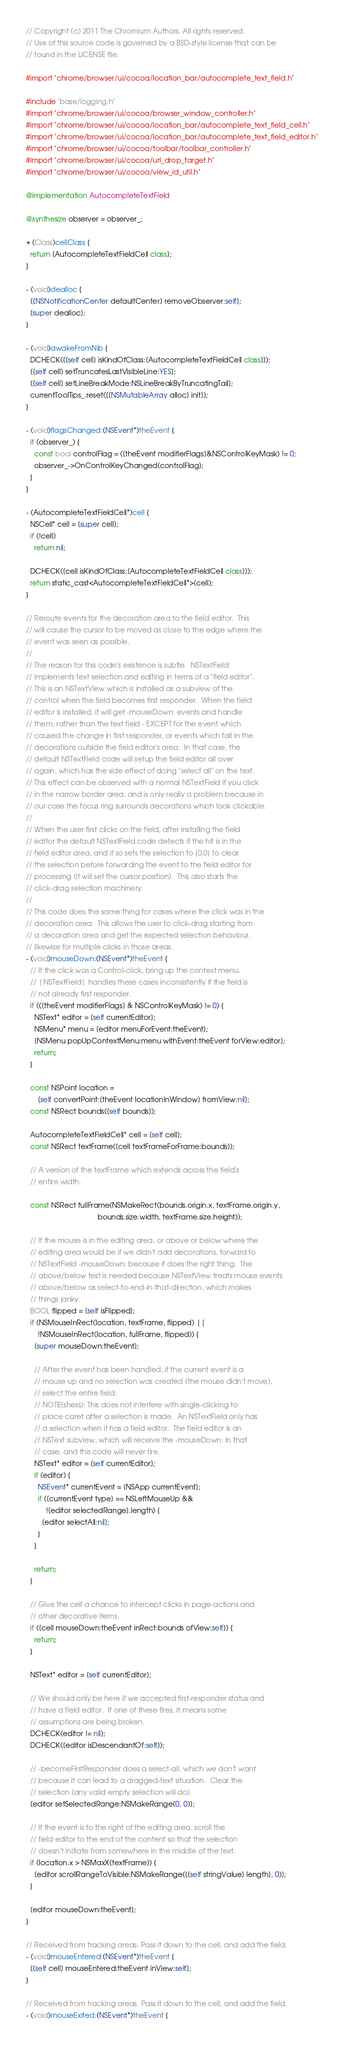<code> <loc_0><loc_0><loc_500><loc_500><_ObjectiveC_>// Copyright (c) 2011 The Chromium Authors. All rights reserved.
// Use of this source code is governed by a BSD-style license that can be
// found in the LICENSE file.

#import "chrome/browser/ui/cocoa/location_bar/autocomplete_text_field.h"

#include "base/logging.h"
#import "chrome/browser/ui/cocoa/browser_window_controller.h"
#import "chrome/browser/ui/cocoa/location_bar/autocomplete_text_field_cell.h"
#import "chrome/browser/ui/cocoa/location_bar/autocomplete_text_field_editor.h"
#import "chrome/browser/ui/cocoa/toolbar/toolbar_controller.h"
#import "chrome/browser/ui/cocoa/url_drop_target.h"
#import "chrome/browser/ui/cocoa/view_id_util.h"

@implementation AutocompleteTextField

@synthesize observer = observer_;

+ (Class)cellClass {
  return [AutocompleteTextFieldCell class];
}

- (void)dealloc {
  [[NSNotificationCenter defaultCenter] removeObserver:self];
  [super dealloc];
}

- (void)awakeFromNib {
  DCHECK([[self cell] isKindOfClass:[AutocompleteTextFieldCell class]]);
  [[self cell] setTruncatesLastVisibleLine:YES];
  [[self cell] setLineBreakMode:NSLineBreakByTruncatingTail];
  currentToolTips_.reset([[NSMutableArray alloc] init]);
}

- (void)flagsChanged:(NSEvent*)theEvent {
  if (observer_) {
    const bool controlFlag = ([theEvent modifierFlags]&NSControlKeyMask) != 0;
    observer_->OnControlKeyChanged(controlFlag);
  }
}

- (AutocompleteTextFieldCell*)cell {
  NSCell* cell = [super cell];
  if (!cell)
    return nil;

  DCHECK([cell isKindOfClass:[AutocompleteTextFieldCell class]]);
  return static_cast<AutocompleteTextFieldCell*>(cell);
}

// Reroute events for the decoration area to the field editor.  This
// will cause the cursor to be moved as close to the edge where the
// event was seen as possible.
//
// The reason for this code's existence is subtle.  NSTextField
// implements text selection and editing in terms of a "field editor".
// This is an NSTextView which is installed as a subview of the
// control when the field becomes first responder.  When the field
// editor is installed, it will get -mouseDown: events and handle
// them, rather than the text field - EXCEPT for the event which
// caused the change in first responder, or events which fall in the
// decorations outside the field editor's area.  In that case, the
// default NSTextField code will setup the field editor all over
// again, which has the side effect of doing "select all" on the text.
// This effect can be observed with a normal NSTextField if you click
// in the narrow border area, and is only really a problem because in
// our case the focus ring surrounds decorations which look clickable.
//
// When the user first clicks on the field, after installing the field
// editor the default NSTextField code detects if the hit is in the
// field editor area, and if so sets the selection to {0,0} to clear
// the selection before forwarding the event to the field editor for
// processing (it will set the cursor position).  This also starts the
// click-drag selection machinery.
//
// This code does the same thing for cases where the click was in the
// decoration area.  This allows the user to click-drag starting from
// a decoration area and get the expected selection behaviour,
// likewise for multiple clicks in those areas.
- (void)mouseDown:(NSEvent*)theEvent {
  // If the click was a Control-click, bring up the context menu.
  // |NSTextField| handles these cases inconsistently if the field is
  // not already first responder.
  if (([theEvent modifierFlags] & NSControlKeyMask) != 0) {
    NSText* editor = [self currentEditor];
    NSMenu* menu = [editor menuForEvent:theEvent];
    [NSMenu popUpContextMenu:menu withEvent:theEvent forView:editor];
    return;
  }

  const NSPoint location =
      [self convertPoint:[theEvent locationInWindow] fromView:nil];
  const NSRect bounds([self bounds]);

  AutocompleteTextFieldCell* cell = [self cell];
  const NSRect textFrame([cell textFrameForFrame:bounds]);

  // A version of the textFrame which extends across the field's
  // entire width.

  const NSRect fullFrame(NSMakeRect(bounds.origin.x, textFrame.origin.y,
                                    bounds.size.width, textFrame.size.height));

  // If the mouse is in the editing area, or above or below where the
  // editing area would be if we didn't add decorations, forward to
  // NSTextField -mouseDown: because it does the right thing.  The
  // above/below test is needed because NSTextView treats mouse events
  // above/below as select-to-end-in-that-direction, which makes
  // things janky.
  BOOL flipped = [self isFlipped];
  if (NSMouseInRect(location, textFrame, flipped) ||
      !NSMouseInRect(location, fullFrame, flipped)) {
    [super mouseDown:theEvent];

    // After the event has been handled, if the current event is a
    // mouse up and no selection was created (the mouse didn't move),
    // select the entire field.
    // NOTE(shess): This does not interfere with single-clicking to
    // place caret after a selection is made.  An NSTextField only has
    // a selection when it has a field editor.  The field editor is an
    // NSText subview, which will receive the -mouseDown: in that
    // case, and this code will never fire.
    NSText* editor = [self currentEditor];
    if (editor) {
      NSEvent* currentEvent = [NSApp currentEvent];
      if ([currentEvent type] == NSLeftMouseUp &&
          ![editor selectedRange].length) {
        [editor selectAll:nil];
      }
    }

    return;
  }

  // Give the cell a chance to intercept clicks in page-actions and
  // other decorative items.
  if ([cell mouseDown:theEvent inRect:bounds ofView:self]) {
    return;
  }

  NSText* editor = [self currentEditor];

  // We should only be here if we accepted first-responder status and
  // have a field editor.  If one of these fires, it means some
  // assumptions are being broken.
  DCHECK(editor != nil);
  DCHECK([editor isDescendantOf:self]);

  // -becomeFirstResponder does a select-all, which we don't want
  // because it can lead to a dragged-text situation.  Clear the
  // selection (any valid empty selection will do).
  [editor setSelectedRange:NSMakeRange(0, 0)];

  // If the event is to the right of the editing area, scroll the
  // field editor to the end of the content so that the selection
  // doesn't initiate from somewhere in the middle of the text.
  if (location.x > NSMaxX(textFrame)) {
    [editor scrollRangeToVisible:NSMakeRange([[self stringValue] length], 0)];
  }

  [editor mouseDown:theEvent];
}

// Received from tracking areas. Pass it down to the cell, and add the field.
- (void)mouseEntered:(NSEvent*)theEvent {
  [[self cell] mouseEntered:theEvent inView:self];
}

// Received from tracking areas. Pass it down to the cell, and add the field.
- (void)mouseExited:(NSEvent*)theEvent {</code> 